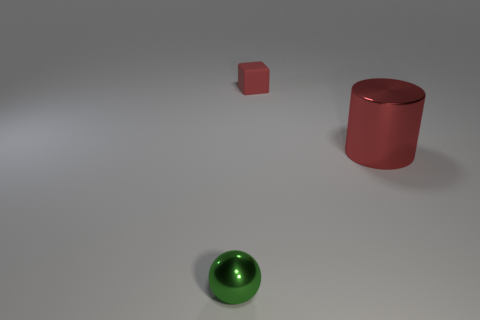Add 2 small blue matte balls. How many objects exist? 5 Subtract 0 yellow cylinders. How many objects are left? 3 Subtract all cylinders. How many objects are left? 2 Subtract all purple cubes. Subtract all cyan balls. How many cubes are left? 1 Subtract all green cylinders. How many cyan cubes are left? 0 Subtract all rubber things. Subtract all large purple shiny spheres. How many objects are left? 2 Add 2 tiny cubes. How many tiny cubes are left? 3 Add 2 small metallic objects. How many small metallic objects exist? 3 